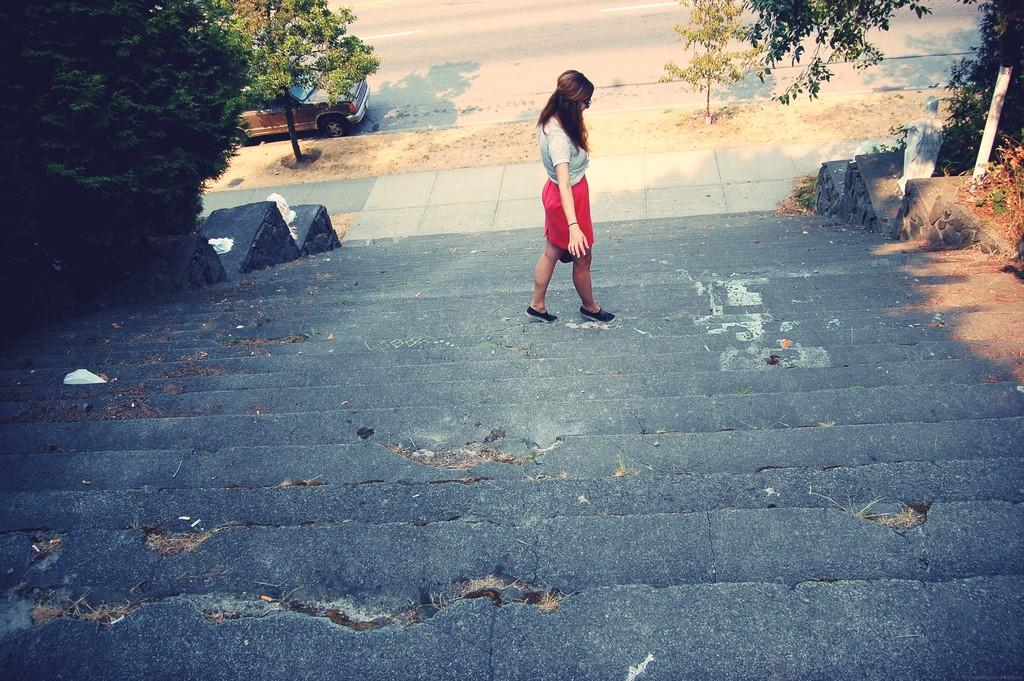Who is the main subject in the image? There is a lady in the image. What is the lady doing in the image? The lady is walking on the stairs. What can be seen on both sides of the image? There are trees on both the right and left sides of the image. What else is present in the image besides the lady and trees? There is a vehicle parked in the image. What type of line can be seen connecting the lady's neck to the vehicle in the image? There is no line connecting the lady's neck to the vehicle in the image. 